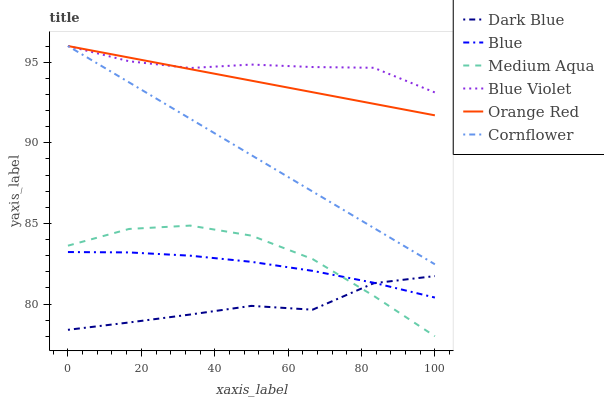Does Dark Blue have the minimum area under the curve?
Answer yes or no. Yes. Does Cornflower have the minimum area under the curve?
Answer yes or no. No. Does Cornflower have the maximum area under the curve?
Answer yes or no. No. Is Dark Blue the roughest?
Answer yes or no. Yes. Is Cornflower the smoothest?
Answer yes or no. No. Is Cornflower the roughest?
Answer yes or no. No. Does Cornflower have the lowest value?
Answer yes or no. No. Does Dark Blue have the highest value?
Answer yes or no. No. Is Dark Blue less than Orange Red?
Answer yes or no. Yes. Is Orange Red greater than Medium Aqua?
Answer yes or no. Yes. Does Dark Blue intersect Orange Red?
Answer yes or no. No. 